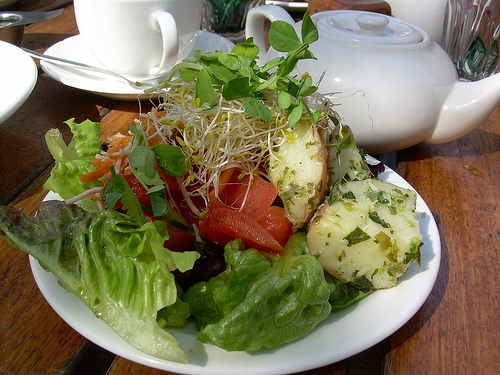<image>
Is the dish on the table? Yes. Looking at the image, I can see the dish is positioned on top of the table, with the table providing support. 